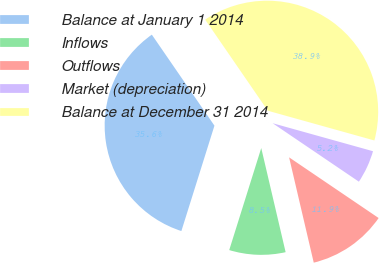Convert chart to OTSL. <chart><loc_0><loc_0><loc_500><loc_500><pie_chart><fcel>Balance at January 1 2014<fcel>Inflows<fcel>Outflows<fcel>Market (depreciation)<fcel>Balance at December 31 2014<nl><fcel>35.57%<fcel>8.5%<fcel>11.86%<fcel>5.15%<fcel>38.92%<nl></chart> 